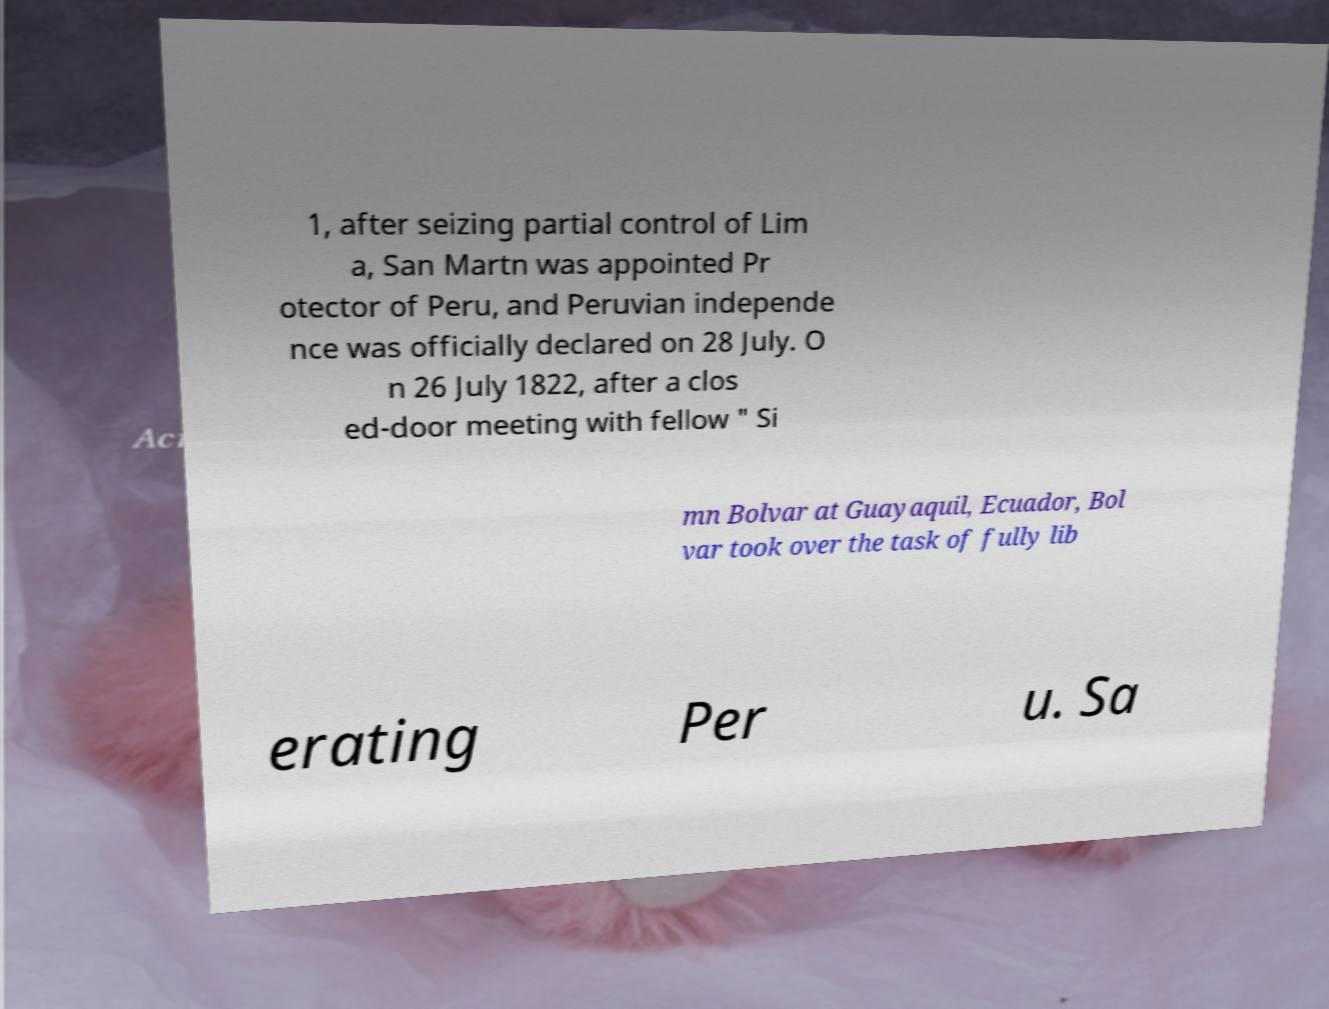Could you assist in decoding the text presented in this image and type it out clearly? 1, after seizing partial control of Lim a, San Martn was appointed Pr otector of Peru, and Peruvian independe nce was officially declared on 28 July. O n 26 July 1822, after a clos ed-door meeting with fellow " Si mn Bolvar at Guayaquil, Ecuador, Bol var took over the task of fully lib erating Per u. Sa 